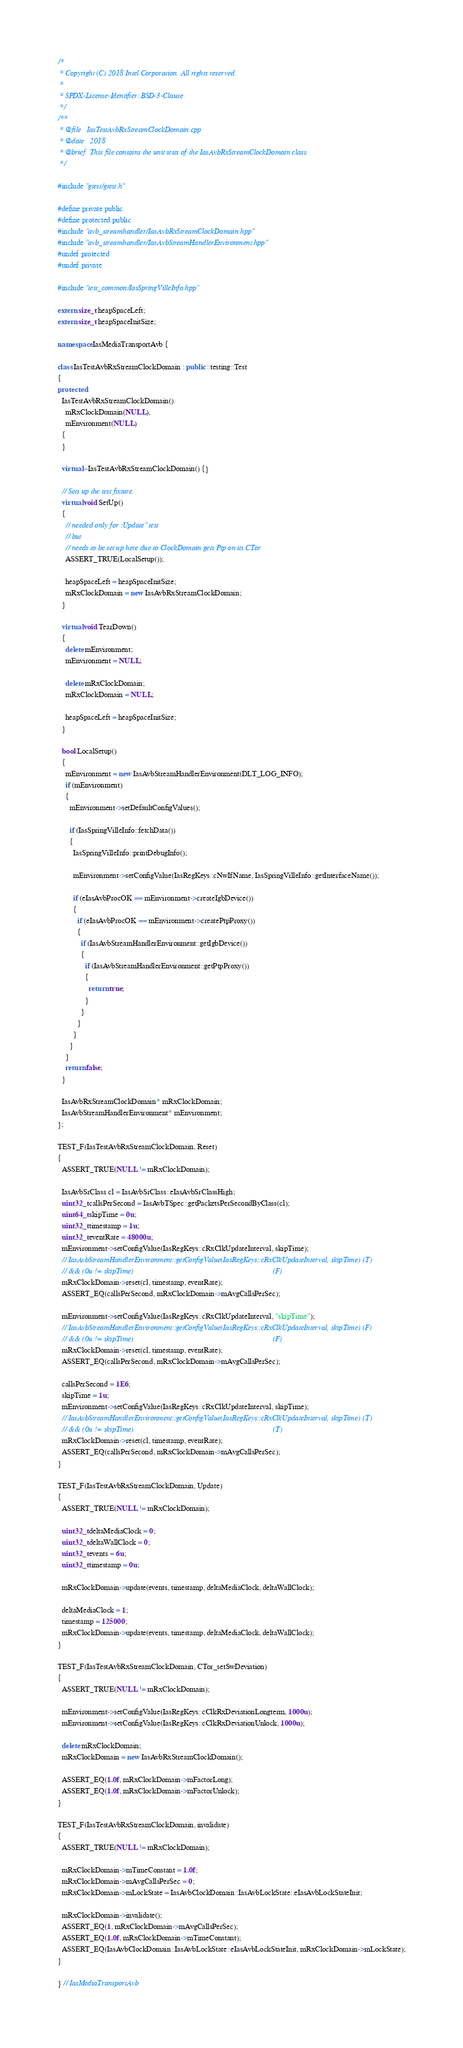Convert code to text. <code><loc_0><loc_0><loc_500><loc_500><_C++_>/*
 * Copyright (C) 2018 Intel Corporation. All rights reserved.
 *
 * SPDX-License-Identifier: BSD-3-Clause
 */
/**
 * @file   IasTestAvbRxStreamClockDomain.cpp
 * @date   2018
 * @brief  This file contains the unit tests of the IasAvbRxStreamClockDomain class.
 */

#include "gtest/gtest.h"

#define private public
#define protected public
#include "avb_streamhandler/IasAvbRxStreamClockDomain.hpp"
#include "avb_streamhandler/IasAvbStreamHandlerEnvironment.hpp"
#undef protected
#undef private

#include "test_common/IasSpringVilleInfo.hpp"

extern size_t heapSpaceLeft;
extern size_t heapSpaceInitSize;

namespace IasMediaTransportAvb {

class IasTestAvbRxStreamClockDomain : public ::testing::Test
{
protected:
  IasTestAvbRxStreamClockDomain():
    mRxClockDomain(NULL),
    mEnvironment(NULL)
  {
  }

  virtual ~IasTestAvbRxStreamClockDomain() {}

  // Sets up the test fixture.
  virtual void SetUp()
  {
    // needed only for :Update" test
    // but
    // needs to be set up here due to ClockDomain gets Ptp on its CTor
    ASSERT_TRUE(LocalSetup());

    heapSpaceLeft = heapSpaceInitSize;
    mRxClockDomain = new IasAvbRxStreamClockDomain;
  }

  virtual void TearDown()
  {
    delete mEnvironment;
    mEnvironment = NULL;

    delete mRxClockDomain;
    mRxClockDomain = NULL;

    heapSpaceLeft = heapSpaceInitSize;
  }

  bool LocalSetup()
  {
    mEnvironment = new IasAvbStreamHandlerEnvironment(DLT_LOG_INFO);
    if (mEnvironment)
    {
      mEnvironment->setDefaultConfigValues();

      if (IasSpringVilleInfo::fetchData())
      {
        IasSpringVilleInfo::printDebugInfo();

        mEnvironment->setConfigValue(IasRegKeys::cNwIfName, IasSpringVilleInfo::getInterfaceName());

        if (eIasAvbProcOK == mEnvironment->createIgbDevice())
        {
          if (eIasAvbProcOK == mEnvironment->createPtpProxy())
          {
            if (IasAvbStreamHandlerEnvironment::getIgbDevice())
            {
              if (IasAvbStreamHandlerEnvironment::getPtpProxy())
              {
                return true;
              }
            }
          }
        }
      }
    }
    return false;
  }

  IasAvbRxStreamClockDomain* mRxClockDomain;
  IasAvbStreamHandlerEnvironment* mEnvironment;
};

TEST_F(IasTestAvbRxStreamClockDomain, Reset)
{
  ASSERT_TRUE(NULL != mRxClockDomain);

  IasAvbSrClass cl = IasAvbSrClass::eIasAvbSrClassHigh;
  uint32_t callsPerSecond = IasAvbTSpec::getPacketsPerSecondByClass(cl);
  uint64_t skipTime = 0u;
  uint32_t timestamp = 1u;
  uint32_t eventRate = 48000u;
  mEnvironment->setConfigValue(IasRegKeys::cRxClkUpdateInterval, skipTime);
  // IasAvbStreamHandlerEnvironment::getConfigValue(IasRegKeys::cRxClkUpdateInterval, skipTime) (T)
  // && (0u != skipTime)                                                                        (F)
  mRxClockDomain->reset(cl, timestamp, eventRate);
  ASSERT_EQ(callsPerSecond, mRxClockDomain->mAvgCallsPerSec);

  mEnvironment->setConfigValue(IasRegKeys::cRxClkUpdateInterval, "skipTime");
  // IasAvbStreamHandlerEnvironment::getConfigValue(IasRegKeys::cRxClkUpdateInterval, skipTime) (F)
  // && (0u != skipTime)                                                                        (F)
  mRxClockDomain->reset(cl, timestamp, eventRate);
  ASSERT_EQ(callsPerSecond, mRxClockDomain->mAvgCallsPerSec);

  callsPerSecond = 1E6;
  skipTime = 1u;
  mEnvironment->setConfigValue(IasRegKeys::cRxClkUpdateInterval, skipTime);
  // IasAvbStreamHandlerEnvironment::getConfigValue(IasRegKeys::cRxClkUpdateInterval, skipTime) (T)
  // && (0u != skipTime)                                                                        (T)
  mRxClockDomain->reset(cl, timestamp, eventRate);
  ASSERT_EQ(callsPerSecond, mRxClockDomain->mAvgCallsPerSec);
}

TEST_F(IasTestAvbRxStreamClockDomain, Update)
{
  ASSERT_TRUE(NULL != mRxClockDomain);

  uint32_t deltaMediaClock = 0;
  uint32_t deltaWallClock = 0;
  uint32_t events = 6u;
  uint32_t timestamp = 0u;

  mRxClockDomain->update(events, timestamp, deltaMediaClock, deltaWallClock);

  deltaMediaClock = 1;
  timestamp = 125000;
  mRxClockDomain->update(events, timestamp, deltaMediaClock, deltaWallClock);
}

TEST_F(IasTestAvbRxStreamClockDomain, CTor_setSwDeviation)
{
  ASSERT_TRUE(NULL != mRxClockDomain);

  mEnvironment->setConfigValue(IasRegKeys::cClkRxDeviationLongterm, 1000u);
  mEnvironment->setConfigValue(IasRegKeys::cClkRxDeviationUnlock, 1000u);

  delete mRxClockDomain;
  mRxClockDomain = new IasAvbRxStreamClockDomain();

  ASSERT_EQ(1.0f, mRxClockDomain->mFactorLong);
  ASSERT_EQ(1.0f, mRxClockDomain->mFactorUnlock);
}

TEST_F(IasTestAvbRxStreamClockDomain, invalidate)
{
  ASSERT_TRUE(NULL != mRxClockDomain);

  mRxClockDomain->mTimeConstant = 1.0f;
  mRxClockDomain->mAvgCallsPerSec = 0;
  mRxClockDomain->mLockState = IasAvbClockDomain::IasAvbLockState::eIasAvbLockStateInit;

  mRxClockDomain->invalidate();
  ASSERT_EQ(1, mRxClockDomain->mAvgCallsPerSec);
  ASSERT_EQ(1.0f, mRxClockDomain->mTimeConstant);
  ASSERT_EQ(IasAvbClockDomain::IasAvbLockState::eIasAvbLockStateInit, mRxClockDomain->mLockState);
}

} // IasMediaTransportAvb
</code> 